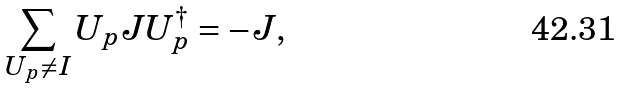Convert formula to latex. <formula><loc_0><loc_0><loc_500><loc_500>\sum _ { U _ { p } \neq I } U _ { p } J U _ { p } ^ { \dagger } = - J ,</formula> 